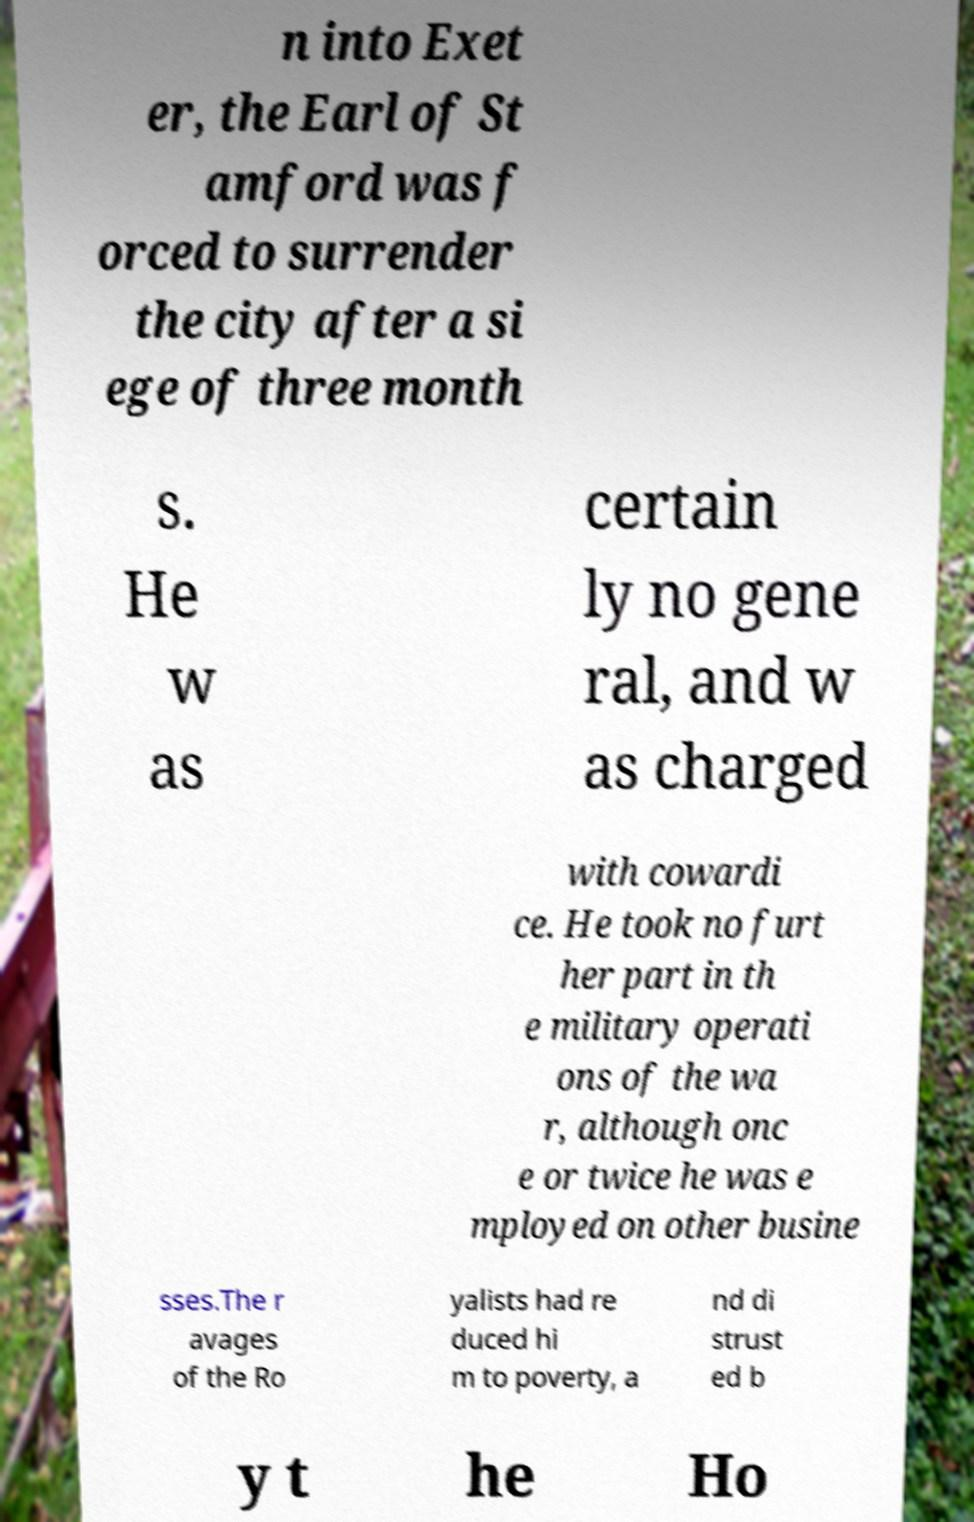Could you assist in decoding the text presented in this image and type it out clearly? n into Exet er, the Earl of St amford was f orced to surrender the city after a si ege of three month s. He w as certain ly no gene ral, and w as charged with cowardi ce. He took no furt her part in th e military operati ons of the wa r, although onc e or twice he was e mployed on other busine sses.The r avages of the Ro yalists had re duced hi m to poverty, a nd di strust ed b y t he Ho 